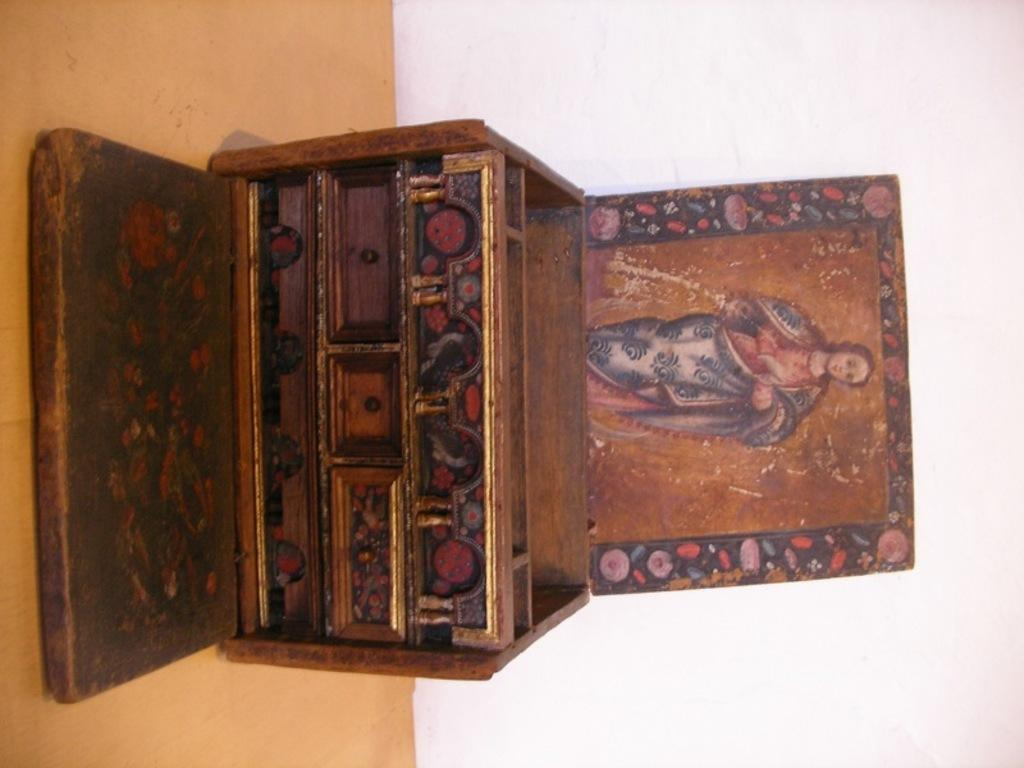What is located in the center of the image? There is a box with its lid opened in the center of the image. What can be seen inside the box? A wooden plank is visible inside the box. What is visible in the background of the image? There is a wall in the background of the image. What is visible at the bottom of the image? The floor is visible at the bottom of the image. Where is the father playing with the children on the playground in the image? There is no father or playground present in the image; it only features a box with its lid opened and a wooden plank inside it. 